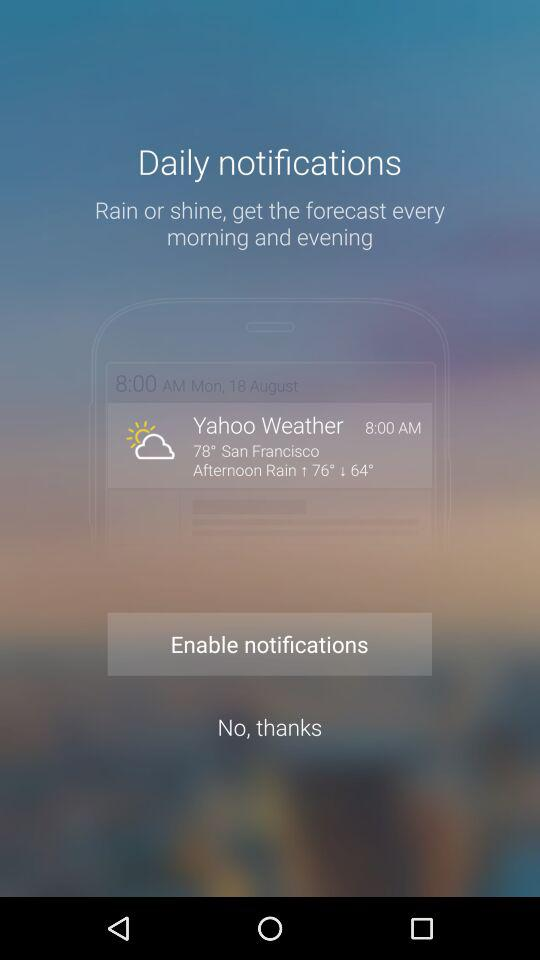What is the temperature in San Francisco? The temperature in San Francisco is 78°. 